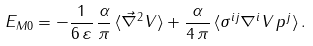<formula> <loc_0><loc_0><loc_500><loc_500>E _ { M 0 } = - \frac { 1 } { 6 \, \varepsilon } \, \frac { \alpha } { \pi } \, \langle \vec { \nabla } ^ { 2 } V \rangle + \frac { \alpha } { 4 \, \pi } \, \langle \sigma ^ { i j } \nabla ^ { i } V \, p ^ { j } \rangle \, .</formula> 